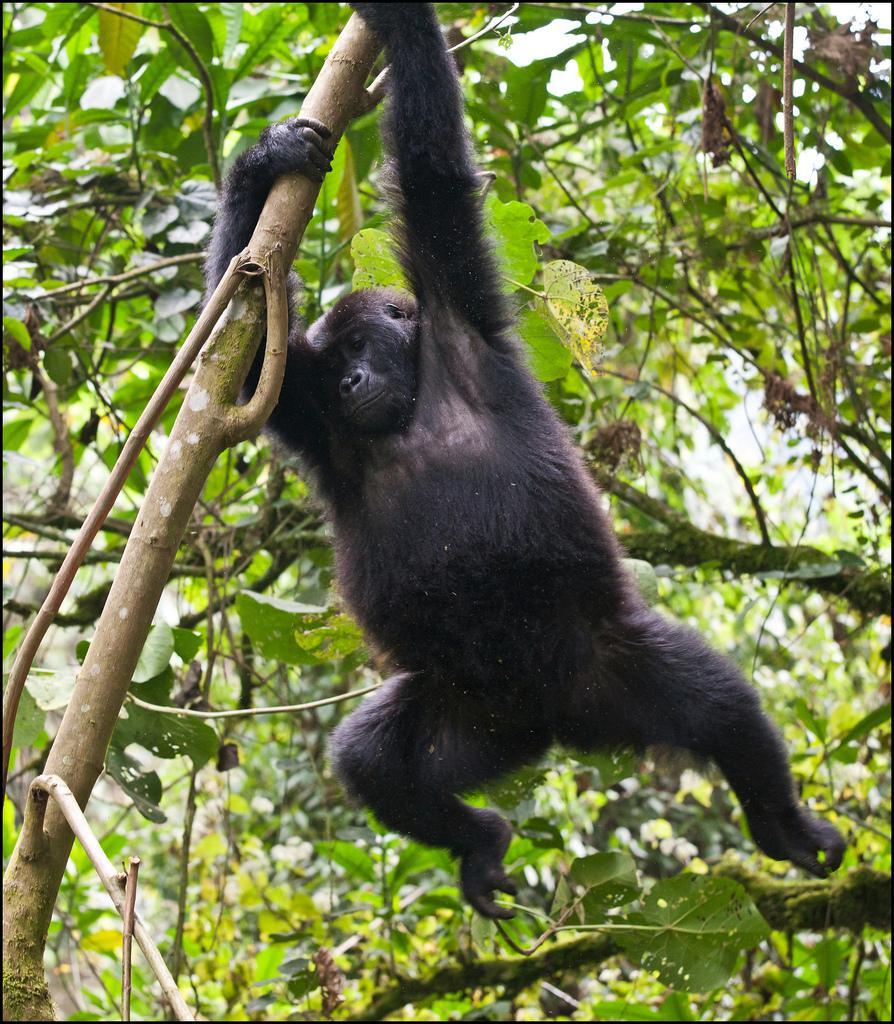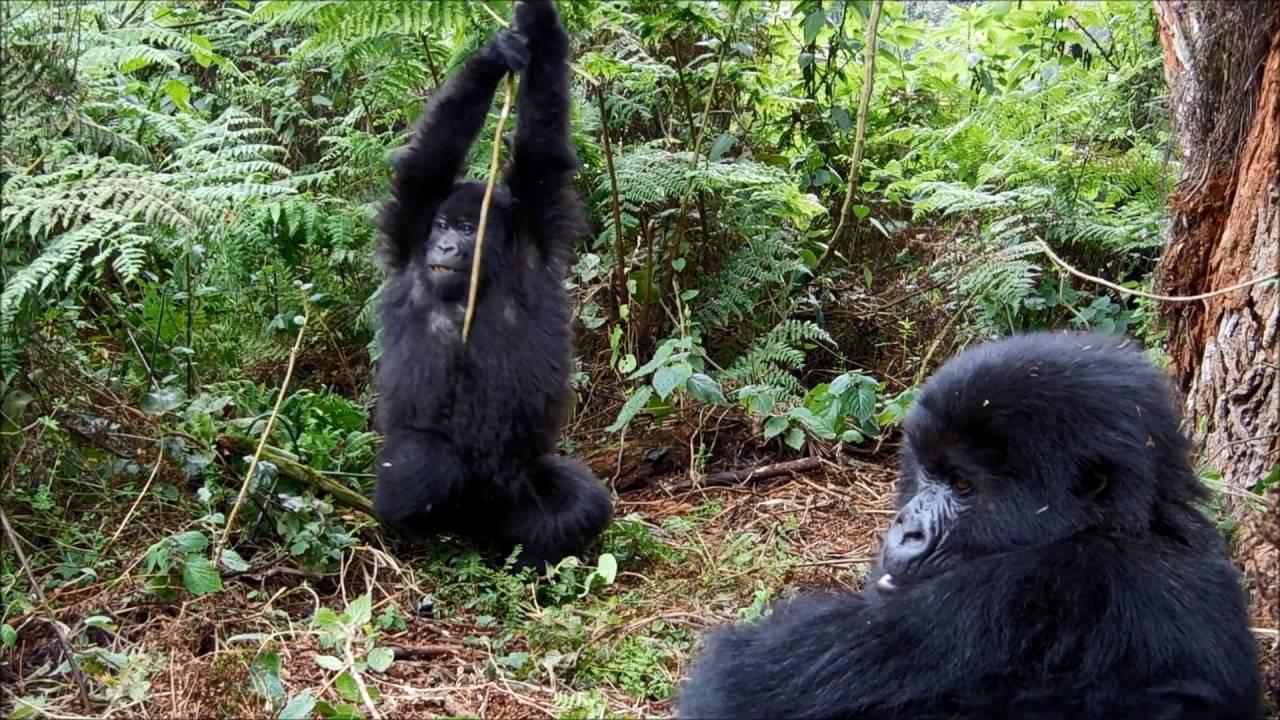The first image is the image on the left, the second image is the image on the right. For the images displayed, is the sentence "Each image contains just one ape, and each ape is hanging from a branch-like growth." factually correct? Answer yes or no. No. The first image is the image on the left, the second image is the image on the right. Given the left and right images, does the statement "At least one ape is on the ground." hold true? Answer yes or no. Yes. 